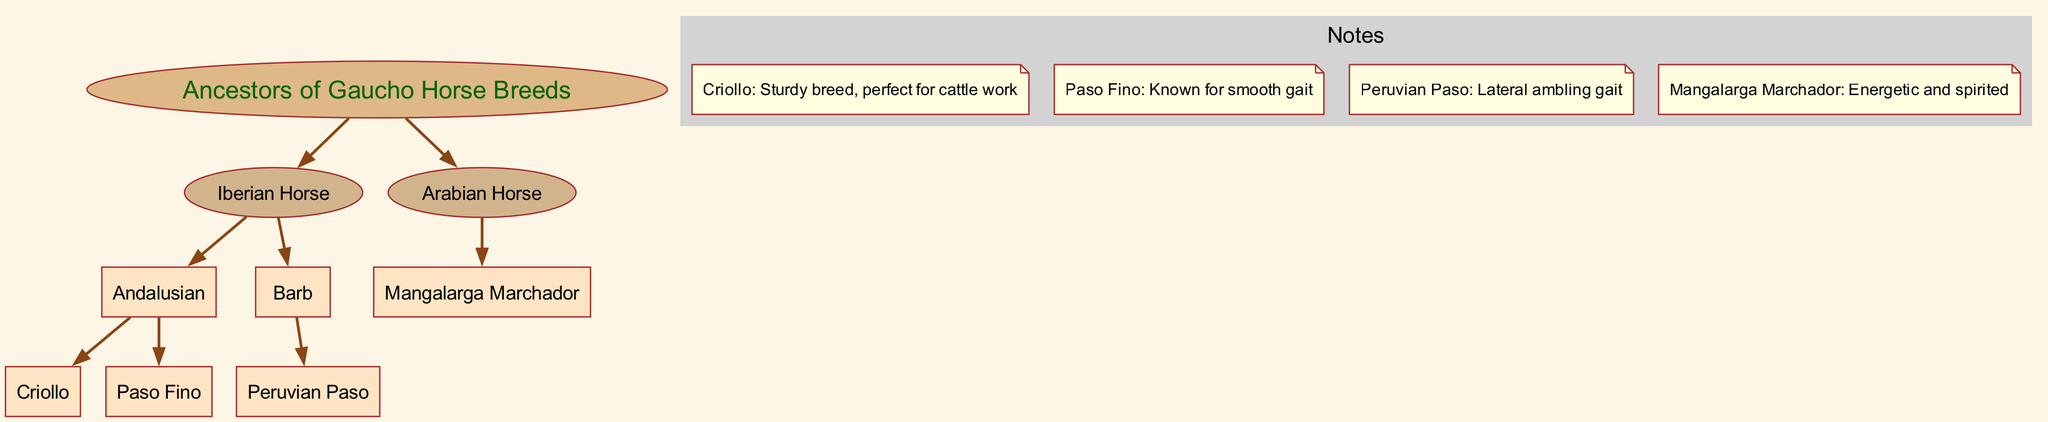What is the root of the family tree? The root of the family tree is the main ancestor node, which is labeled "Ancestors of Gaucho Horse Breeds" in the diagram.
Answer: Ancestors of Gaucho Horse Breeds How many main branches are there? The diagram has two main branches extending from the root: "Iberian Horse" and "Arabian Horse".
Answer: 2 Which breed is the child of the Iberian Horse that is known for a smooth gait? Among the children of the Iberian Horse, the breed known for a smooth gait is "Paso Fino".
Answer: Paso Fino How many breeds are descendants of the Arabian Horse? The Arabian Horse has one direct descendant shown in the diagram, which is "Mangalarga Marchador".
Answer: 1 What is one characteristic noted for the Criollo breed? The diagram notes that the Criollo breed is "Sturdy breed, perfect for cattle work".
Answer: Sturdy breed, perfect for cattle work Which breed associated with gauchos has a lateral ambling gait? The breed with a lateral ambling gait is "Peruvian Paso".
Answer: Peruvian Paso Name a horse breed that is a descendant of both Iberian Horse and Barb? The horse breed "Peruvian Paso" is a descendant of the Barb, while "Criollo" and "Paso Fino" are descendants of the Iberian Horse, indicating there is no direct breed that is a descendant of both in the diagram.
Answer: None What are the parent breeds of the Criollo horse? The Criollo horse is a descendant of the Andalusian horse, which is a child of the Iberian Horse. This makes the Iberian Horse the grandparent of the Criollo.
Answer: Iberian Horse Which breed is depicted as having more than one descendant? The "Iberian Horse" is depicted as having two descendants, the "Andalusian" and the "Barb".
Answer: Iberian Horse 